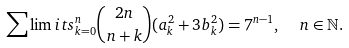<formula> <loc_0><loc_0><loc_500><loc_500>\sum \lim i t s _ { k = 0 } ^ { n } \binom { 2 n } { n + k } ( a _ { k } ^ { 2 } + 3 b _ { k } ^ { 2 } ) = 7 ^ { n - 1 } , \ \ n \in \mathbb { N } .</formula> 